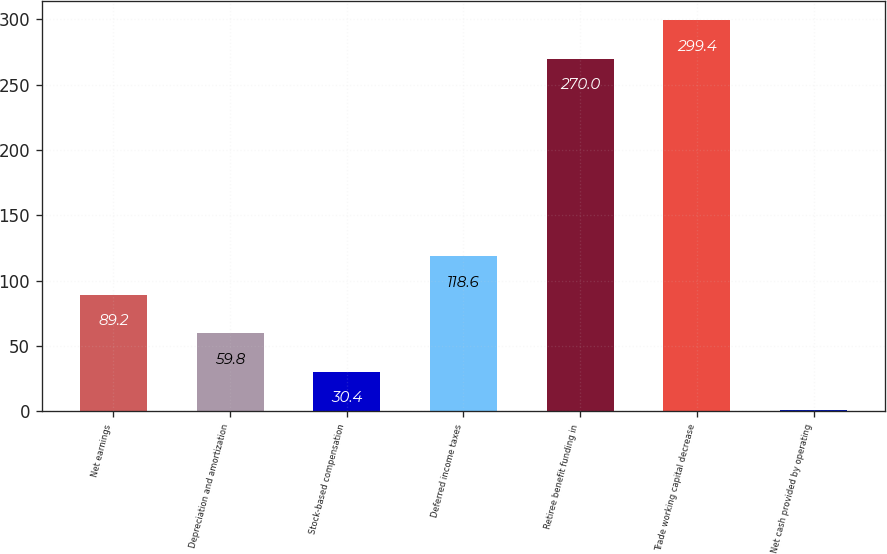<chart> <loc_0><loc_0><loc_500><loc_500><bar_chart><fcel>Net earnings<fcel>Depreciation and amortization<fcel>Stock-based compensation<fcel>Deferred income taxes<fcel>Retiree benefit funding in<fcel>Trade working capital decrease<fcel>Net cash provided by operating<nl><fcel>89.2<fcel>59.8<fcel>30.4<fcel>118.6<fcel>270<fcel>299.4<fcel>1<nl></chart> 